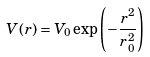Convert formula to latex. <formula><loc_0><loc_0><loc_500><loc_500>V ( r ) = V _ { 0 } \exp \left ( - \frac { r ^ { 2 } } { r _ { 0 } ^ { 2 } } \right )</formula> 